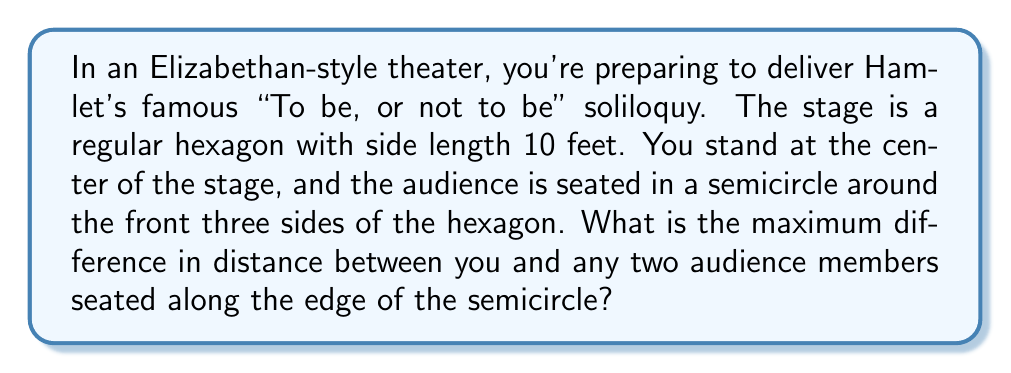Help me with this question. Let's approach this step-by-step:

1) First, we need to understand the geometry of the stage. A regular hexagon has 6 equal sides and 6 equal angles of 120°.

2) The audience is seated along a semicircle that touches the front three sides of the hexagon. This semicircle will have its center at the center of the hexagon, where you are standing.

3) The radius of this semicircle will be equal to the distance from the center of the hexagon to any of its vertices. In a regular hexagon, this distance is equal to the side length. So the radius is 10 feet.

4) The maximum difference in distance will be between the closest and farthest audience members.

5) The closest audience members will be directly in front of you, at a distance of 10 feet (the radius of the semicircle).

6) The farthest audience members will be at the ends of the semicircle, which align with the vertices of the hexagon that are not part of the front three sides.

7) To find the distance to these farthest points, we need to use the Pythagorean theorem. If we draw a line from the center to one of these points, it forms a 30-60-90 triangle with half of one of the hexagon's sides.

8) In a 30-60-90 triangle, if the shortest side (opposite to the 30° angle) is x, then the hypotenuse is 2x, and the remaining side is $x\sqrt{3}$.

9) Half of the hexagon's side is 5 feet, so this corresponds to $x\sqrt{3}$ in our 30-60-90 triangle.

10) Therefore, $5 = x\sqrt{3}$, so $x = \frac{5}{\sqrt{3}}$.

11) The hypotenuse of this triangle, which is the distance to the farthest audience members, is $2x = \frac{10}{\sqrt{3}}$.

12) The difference between the farthest and closest distances is:

   $$\frac{10}{\sqrt{3}} - 10 = 10(\frac{1}{\sqrt{3}} - 1) \approx 2.24 \text{ feet}$$

[asy]
import geometry;

unitsize(10cm);

pair A = (0,0);
pair B = (1,0);
pair C = rotate(60)*B;
pair D = rotate(60)*C;
pair E = rotate(60)*D;
pair F = rotate(60)*E;

draw(A--B--C--D--E--F--cycle);
draw(arc(A,1,0,180), red);
dot(A,blue);

label("You", A, S);
label("Stage", (0.5,0.3));
label("Audience", (0,-0.6), red);

dot((1,0), green);
dot(rotate(120)*(1,0), green);

label("Closest", (0.5,-0.1), green);
label("Farthest", (rotate(120)*(1,0)), NE, green);
[/asy]
Answer: $10(\frac{1}{\sqrt{3}} - 1)$ feet 